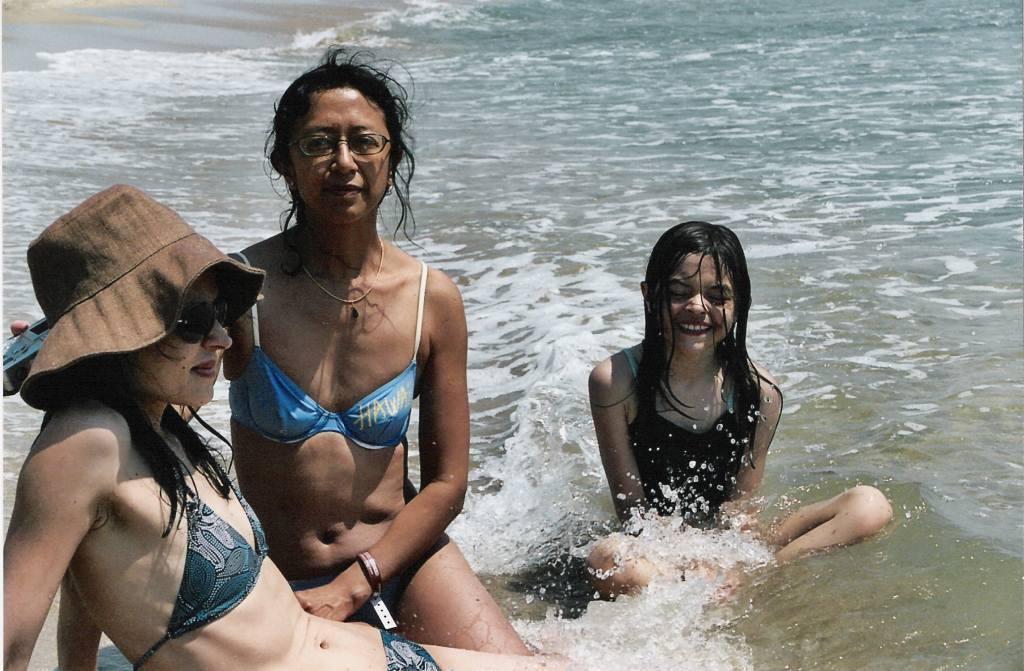Could you give a brief overview of what you see in this image? In this picture, we can see a few people sitting on the ground, and we can see water. 